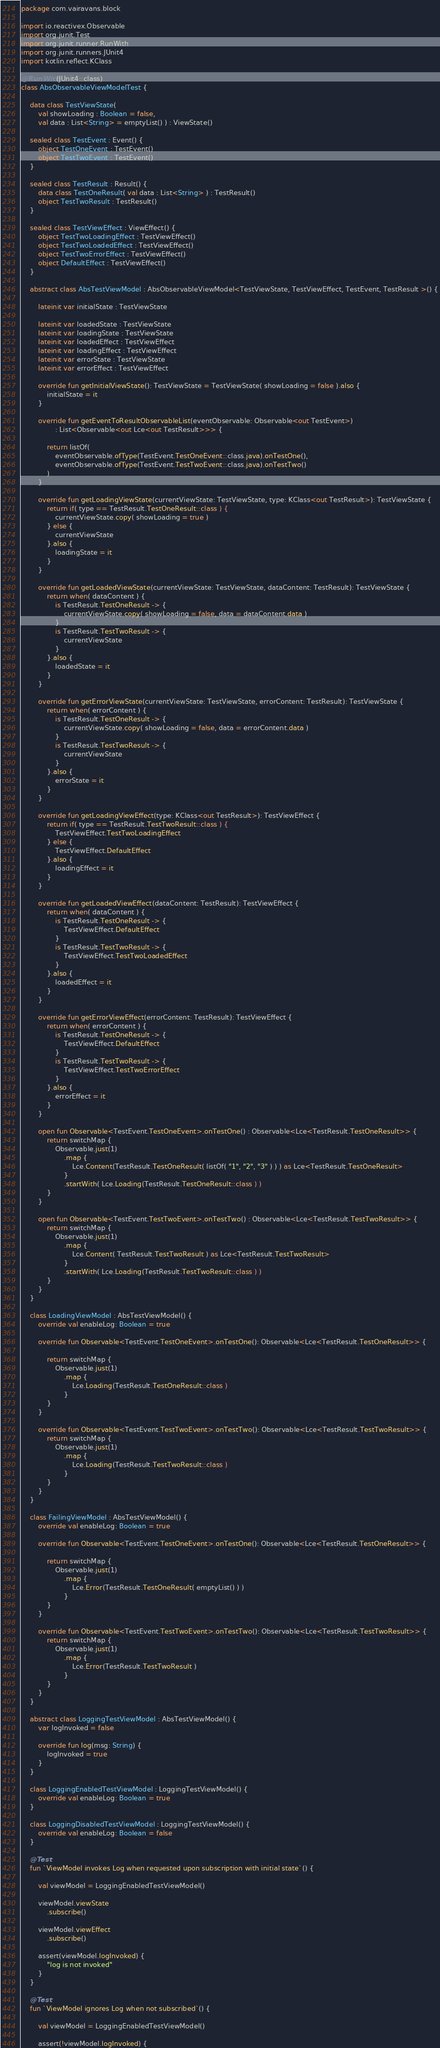Convert code to text. <code><loc_0><loc_0><loc_500><loc_500><_Kotlin_>package com.vairavans.block

import io.reactivex.Observable
import org.junit.Test
import org.junit.runner.RunWith
import org.junit.runners.JUnit4
import kotlin.reflect.KClass

@RunWith(JUnit4::class)
class AbsObservableViewModelTest {

    data class TestViewState(
        val showLoading : Boolean = false,
        val data : List<String> = emptyList() ) : ViewState()

    sealed class TestEvent : Event() {
        object TestOneEvent : TestEvent()
        object TestTwoEvent : TestEvent()
    }

    sealed class TestResult : Result() {
        data class TestOneResult( val data : List<String> ) : TestResult()
        object TestTwoResult : TestResult()
    }

    sealed class TestViewEffect : ViewEffect() {
        object TestTwoLoadingEffect : TestViewEffect()
        object TestTwoLoadedEffect : TestViewEffect()
        object TestTwoErrorEffect : TestViewEffect()
        object DefaultEffect : TestViewEffect()
    }

    abstract class AbsTestViewModel : AbsObservableViewModel<TestViewState, TestViewEffect, TestEvent, TestResult >() {

        lateinit var initialState : TestViewState

        lateinit var loadedState : TestViewState
        lateinit var loadingState : TestViewState
        lateinit var loadedEffect : TestViewEffect
        lateinit var loadingEffect : TestViewEffect
        lateinit var errorState : TestViewState
        lateinit var errorEffect : TestViewEffect

        override fun getInitialViewState(): TestViewState = TestViewState( showLoading = false ).also {
            initialState = it
        }

        override fun getEventToResultObservableList(eventObservable: Observable<out TestEvent>)
                : List<Observable<out Lce<out TestResult>>> {

            return listOf(
                eventObservable.ofType(TestEvent.TestOneEvent::class.java).onTestOne(),
                eventObservable.ofType(TestEvent.TestTwoEvent::class.java).onTestTwo()
            )
        }

        override fun getLoadingViewState(currentViewState: TestViewState, type: KClass<out TestResult>): TestViewState {
            return if( type == TestResult.TestOneResult::class ) {
                currentViewState.copy( showLoading = true )
            } else {
                currentViewState
            }.also {
                loadingState = it
            }
        }

        override fun getLoadedViewState(currentViewState: TestViewState, dataContent: TestResult): TestViewState {
            return when( dataContent ) {
                is TestResult.TestOneResult -> {
                    currentViewState.copy( showLoading = false, data = dataContent.data )
                }
                is TestResult.TestTwoResult -> {
                    currentViewState
                }
            }.also {
                loadedState = it
            }
        }

        override fun getErrorViewState(currentViewState: TestViewState, errorContent: TestResult): TestViewState {
            return when( errorContent ) {
                is TestResult.TestOneResult -> {
                    currentViewState.copy( showLoading = false, data = errorContent.data )
                }
                is TestResult.TestTwoResult -> {
                    currentViewState
                }
            }.also {
                errorState = it
            }
        }

        override fun getLoadingViewEffect(type: KClass<out TestResult>): TestViewEffect {
            return if( type == TestResult.TestTwoResult::class ) {
                TestViewEffect.TestTwoLoadingEffect
            } else {
                TestViewEffect.DefaultEffect
            }.also {
                loadingEffect = it
            }
        }

        override fun getLoadedViewEffect(dataContent: TestResult): TestViewEffect {
            return when( dataContent ) {
                is TestResult.TestOneResult -> {
                    TestViewEffect.DefaultEffect
                }
                is TestResult.TestTwoResult -> {
                    TestViewEffect.TestTwoLoadedEffect
                }
            }.also {
                loadedEffect = it
            }
        }

        override fun getErrorViewEffect(errorContent: TestResult): TestViewEffect {
            return when( errorContent ) {
                is TestResult.TestOneResult -> {
                    TestViewEffect.DefaultEffect
                }
                is TestResult.TestTwoResult -> {
                    TestViewEffect.TestTwoErrorEffect
                }
            }.also {
                errorEffect = it
            }
        }

        open fun Observable<TestEvent.TestOneEvent>.onTestOne() : Observable<Lce<TestResult.TestOneResult>> {
            return switchMap {
                Observable.just(1)
                    .map {
                        Lce.Content(TestResult.TestOneResult( listOf( "1", "2", "3" ) ) ) as Lce<TestResult.TestOneResult>
                    }
                    .startWith( Lce.Loading(TestResult.TestOneResult::class ) )
            }
        }

        open fun Observable<TestEvent.TestTwoEvent>.onTestTwo() : Observable<Lce<TestResult.TestTwoResult>> {
            return switchMap {
                Observable.just(1)
                    .map {
                        Lce.Content( TestResult.TestTwoResult ) as Lce<TestResult.TestTwoResult>
                    }
                    .startWith( Lce.Loading(TestResult.TestTwoResult::class ) )
            }
        }
    }

    class LoadingViewModel : AbsTestViewModel() {
        override val enableLog: Boolean = true

        override fun Observable<TestEvent.TestOneEvent>.onTestOne(): Observable<Lce<TestResult.TestOneResult>> {

            return switchMap {
                Observable.just(1)
                    .map {
                        Lce.Loading(TestResult.TestOneResult::class )
                    }
            }
        }

        override fun Observable<TestEvent.TestTwoEvent>.onTestTwo(): Observable<Lce<TestResult.TestTwoResult>> {
            return switchMap {
                Observable.just(1)
                    .map {
                        Lce.Loading(TestResult.TestTwoResult::class )
                    }
            }
        }
    }

    class FailingViewModel : AbsTestViewModel() {
        override val enableLog: Boolean = true

        override fun Observable<TestEvent.TestOneEvent>.onTestOne(): Observable<Lce<TestResult.TestOneResult>> {

            return switchMap {
                Observable.just(1)
                    .map {
                        Lce.Error(TestResult.TestOneResult( emptyList() ) )
                    }
            }
        }

        override fun Observable<TestEvent.TestTwoEvent>.onTestTwo(): Observable<Lce<TestResult.TestTwoResult>> {
            return switchMap {
                Observable.just(1)
                    .map {
                        Lce.Error(TestResult.TestTwoResult )
                    }
            }
        }
    }

    abstract class LoggingTestViewModel : AbsTestViewModel() {
        var logInvoked = false

        override fun log(msg: String) {
            logInvoked = true
        }
    }

    class LoggingEnabledTestViewModel : LoggingTestViewModel() {
        override val enableLog: Boolean = true
    }

    class LoggingDisabledTestViewModel : LoggingTestViewModel() {
        override val enableLog: Boolean = false
    }

    @Test
    fun `ViewModel invokes Log when requested upon subscription with initial state`() {

        val viewModel = LoggingEnabledTestViewModel()

        viewModel.viewState
            .subscribe()

        viewModel.viewEffect
            .subscribe()

        assert(viewModel.logInvoked) {
            "log is not invoked"
        }
    }

    @Test
    fun `ViewModel ignores Log when not subscribed`() {

        val viewModel = LoggingEnabledTestViewModel()

        assert(!viewModel.logInvoked) {</code> 